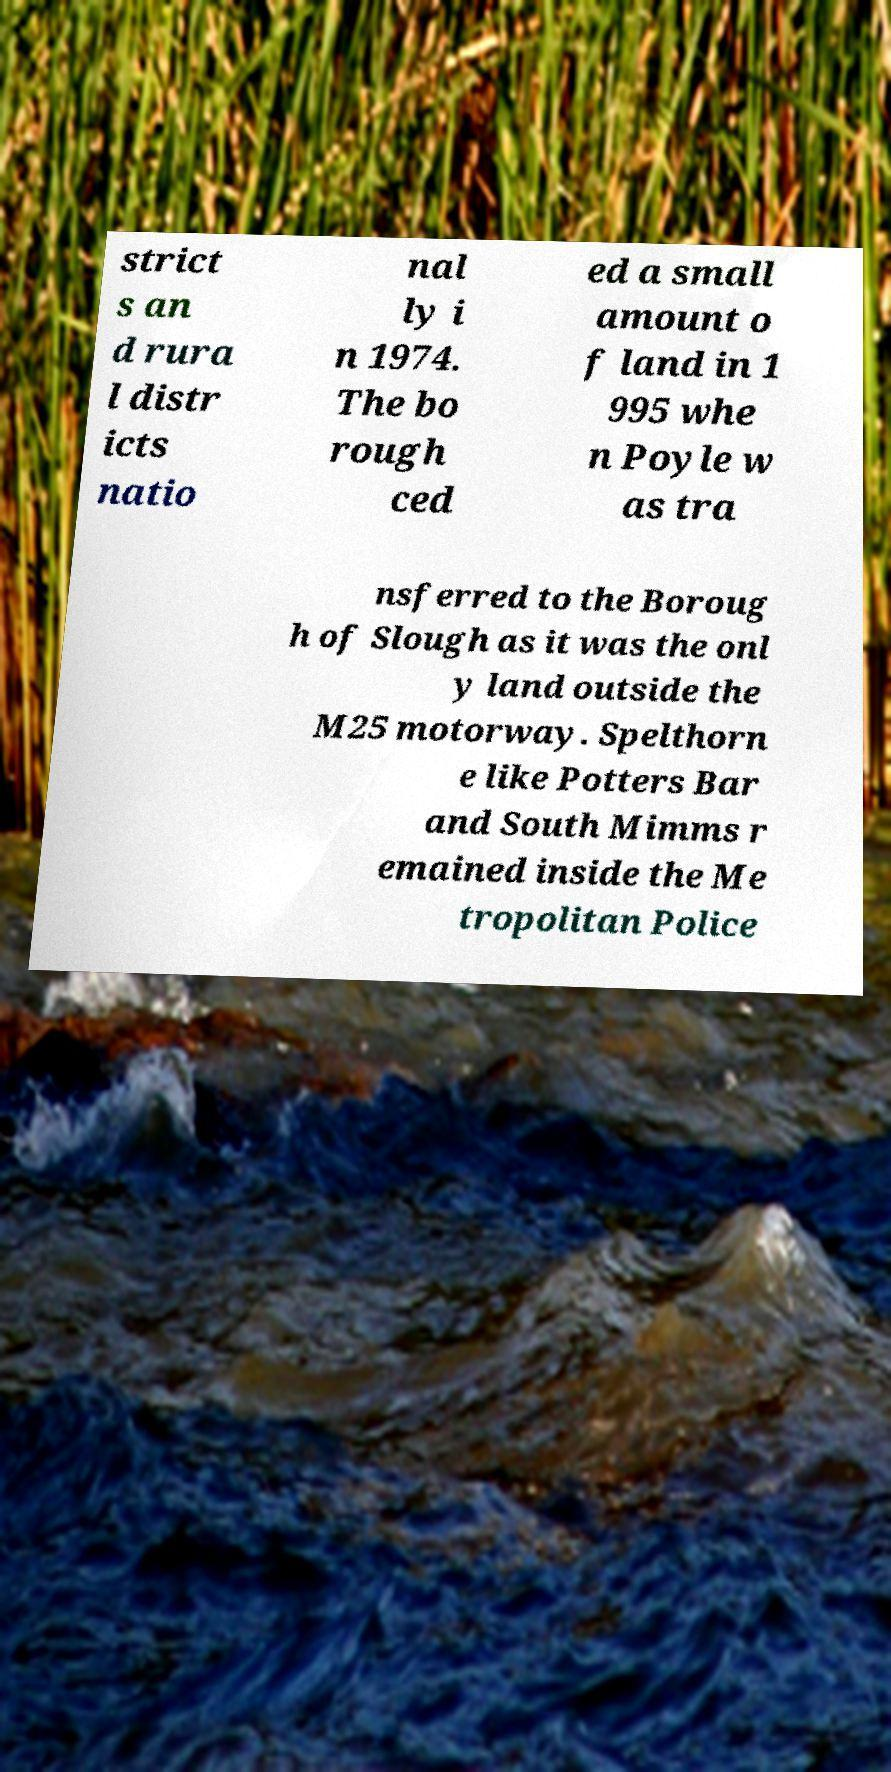Can you read and provide the text displayed in the image?This photo seems to have some interesting text. Can you extract and type it out for me? strict s an d rura l distr icts natio nal ly i n 1974. The bo rough ced ed a small amount o f land in 1 995 whe n Poyle w as tra nsferred to the Boroug h of Slough as it was the onl y land outside the M25 motorway. Spelthorn e like Potters Bar and South Mimms r emained inside the Me tropolitan Police 